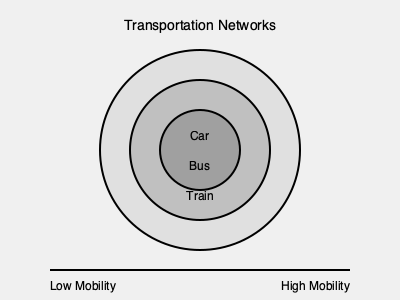Analyze the diagram depicting different transportation modes and their reach. How does the expansion of transportation networks, particularly the introduction of high-speed rail systems, impact social mobility in urban and rural areas? Consider the concept of time-space compression in your analysis. 1. Interpret the diagram:
   - The concentric circles represent different transportation modes (car, bus, train) and their reach.
   - The outer circle (train) has the largest reach, followed by bus and car.

2. Understand time-space compression:
   - Time-space compression refers to the reduction in the time and cost of communication and transportation.
   - As transportation technology improves, distances become less significant barriers to social and economic interactions.

3. Analyze the impact of high-speed rail:
   - High-speed rail systems significantly reduce travel times between urban centers and rural areas.
   - This reduction in travel time effectively "shrinks" geographical distances.

4. Consider urban-rural connections:
   - Improved transportation networks increase connectivity between urban and rural areas.
   - Rural residents gain better access to urban job markets, educational institutions, and cultural resources.

5. Evaluate social mobility effects:
   - Enhanced transportation networks expand individuals' geographical reach for opportunities.
   - This expansion can lead to:
     a) Increased job prospects
     b) Better educational access
     c) Wider social networks
   - All of these factors contribute to improved social mobility potential.

6. Quantify the impact:
   - Let $M$ represent social mobility potential, $T$ represent travel time, and $O$ represent opportunities.
   - We can express this relationship as: $M \propto \frac{O}{T}$
   - As $T$ decreases due to improved transportation, $M$ increases.

7. Consider potential drawbacks:
   - Gentrification in areas newly connected by high-speed rail
   - Potential loss of local culture and identity in rural areas

8. Conclusion:
   - The expansion of transportation networks, especially high-speed rail, generally increases social mobility by reducing the friction of distance and expanding access to opportunities.
Answer: Expanded transportation networks increase social mobility by reducing time-space barriers, enhancing access to opportunities, and connecting urban and rural areas more efficiently. 